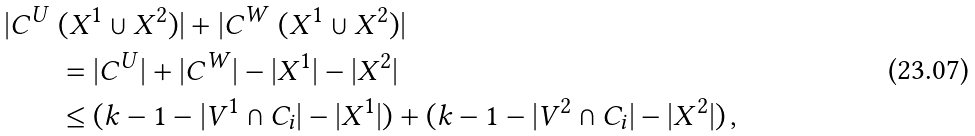<formula> <loc_0><loc_0><loc_500><loc_500>| C ^ { U } \ & ( X ^ { 1 } \cup X ^ { 2 } ) | + | C ^ { W } \ ( X ^ { 1 } \cup X ^ { 2 } ) | \\ & = | C ^ { U } | + | C ^ { W } | - | X ^ { 1 } | - | X ^ { 2 } | \\ & \leq ( k - 1 - | V ^ { 1 } \cap C _ { i } | - | X ^ { 1 } | ) + ( k - 1 - | V ^ { 2 } \cap C _ { i } | - | X ^ { 2 } | ) \, ,</formula> 